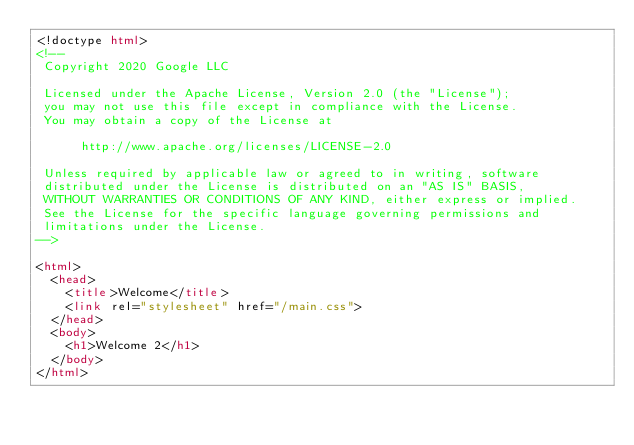Convert code to text. <code><loc_0><loc_0><loc_500><loc_500><_HTML_><!doctype html>
<!--
 Copyright 2020 Google LLC

 Licensed under the Apache License, Version 2.0 (the "License");
 you may not use this file except in compliance with the License.
 You may obtain a copy of the License at

      http://www.apache.org/licenses/LICENSE-2.0

 Unless required by applicable law or agreed to in writing, software
 distributed under the License is distributed on an "AS IS" BASIS,
 WITHOUT WARRANTIES OR CONDITIONS OF ANY KIND, either express or implied.
 See the License for the specific language governing permissions and
 limitations under the License.
-->

<html>
	<head>
		<title>Welcome</title>
		<link rel="stylesheet" href="/main.css">
	</head>
	<body>
		<h1>Welcome 2</h1>
	</body>
</html>
</code> 